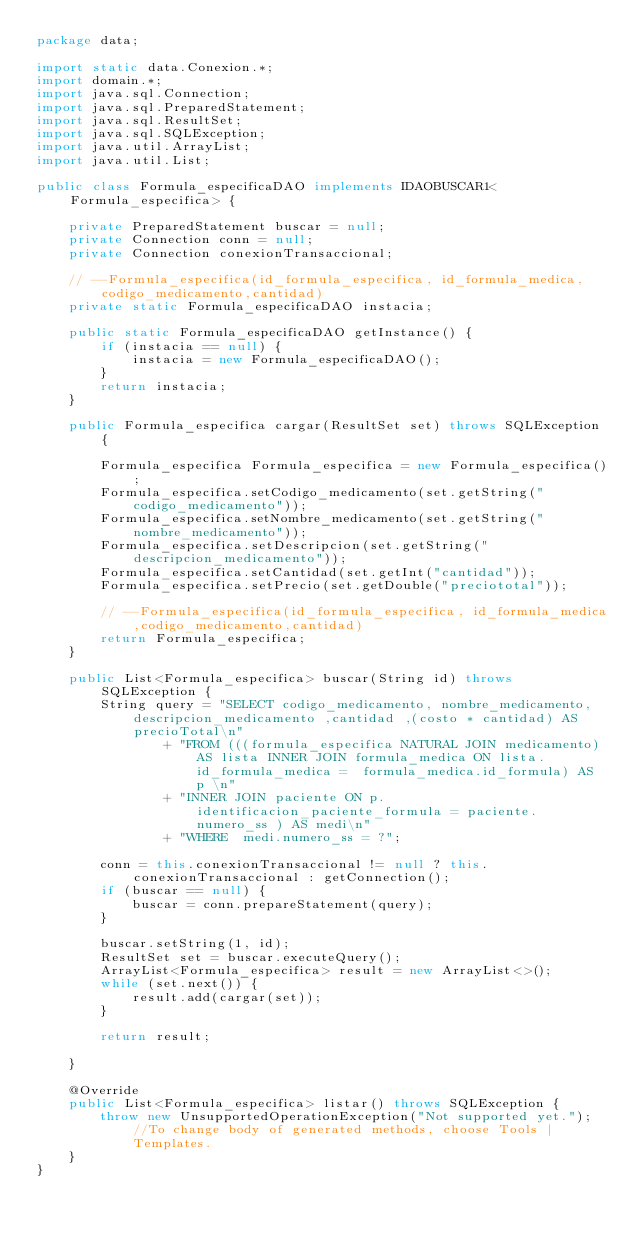<code> <loc_0><loc_0><loc_500><loc_500><_Java_>package data;

import static data.Conexion.*;
import domain.*;
import java.sql.Connection;
import java.sql.PreparedStatement;
import java.sql.ResultSet;
import java.sql.SQLException;
import java.util.ArrayList;
import java.util.List;

public class Formula_especificaDAO implements IDAOBUSCAR1<Formula_especifica> {

    private PreparedStatement buscar = null;
    private Connection conn = null;
    private Connection conexionTransaccional;

    // --Formula_especifica(id_formula_especifica, id_formula_medica,codigo_medicamento,cantidad)
    private static Formula_especificaDAO instacia;

    public static Formula_especificaDAO getInstance() {
        if (instacia == null) {
            instacia = new Formula_especificaDAO();
        }
        return instacia;
    }

    public Formula_especifica cargar(ResultSet set) throws SQLException {

        Formula_especifica Formula_especifica = new Formula_especifica();
        Formula_especifica.setCodigo_medicamento(set.getString("codigo_medicamento"));
        Formula_especifica.setNombre_medicamento(set.getString("nombre_medicamento"));
        Formula_especifica.setDescripcion(set.getString("descripcion_medicamento"));
        Formula_especifica.setCantidad(set.getInt("cantidad"));
        Formula_especifica.setPrecio(set.getDouble("preciototal"));

        // --Formula_especifica(id_formula_especifica, id_formula_medica,codigo_medicamento,cantidad)
        return Formula_especifica;
    }

    public List<Formula_especifica> buscar(String id) throws SQLException {
        String query = "SELECT codigo_medicamento, nombre_medicamento, descripcion_medicamento ,cantidad ,(costo * cantidad) AS precioTotal\n"
                + "FROM (((formula_especifica NATURAL JOIN medicamento) AS lista INNER JOIN formula_medica ON lista.id_formula_medica =  formula_medica.id_formula) AS p \n"
                + "INNER JOIN paciente ON p.identificacion_paciente_formula = paciente.numero_ss ) AS medi\n"
                + "WHERE  medi.numero_ss = ?";

        conn = this.conexionTransaccional != null ? this.conexionTransaccional : getConnection();
        if (buscar == null) {
            buscar = conn.prepareStatement(query);
        }

        buscar.setString(1, id);
        ResultSet set = buscar.executeQuery();
        ArrayList<Formula_especifica> result = new ArrayList<>();
        while (set.next()) {
            result.add(cargar(set));
        }

        return result;

    }

    @Override
    public List<Formula_especifica> listar() throws SQLException {
        throw new UnsupportedOperationException("Not supported yet."); //To change body of generated methods, choose Tools | Templates.
    }
}
</code> 